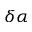Convert formula to latex. <formula><loc_0><loc_0><loc_500><loc_500>\delta \alpha</formula> 